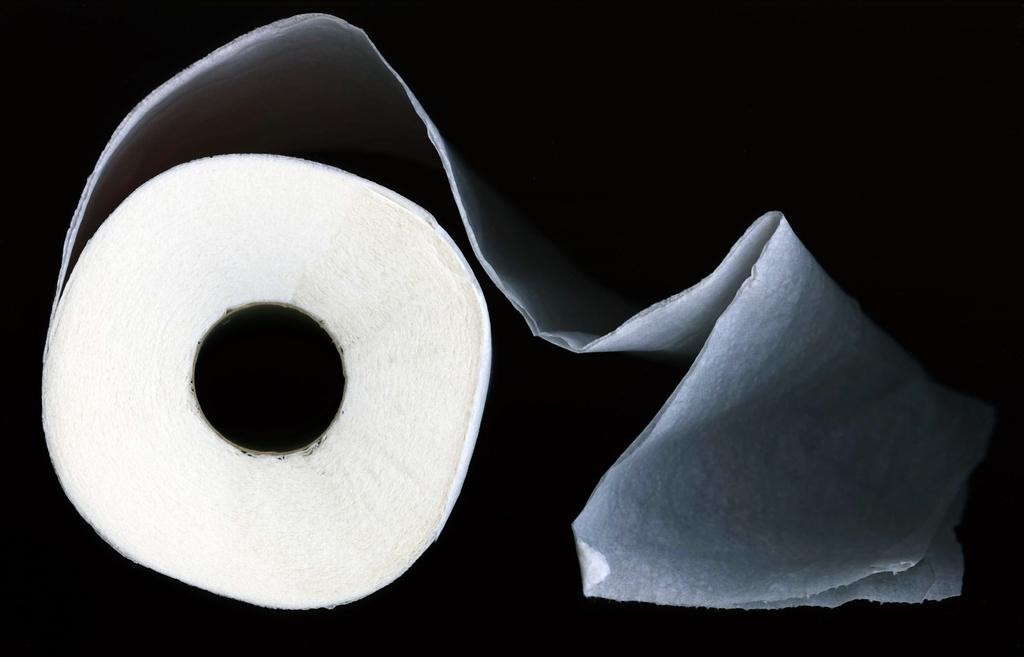What object is located in the front of the image? There is a tissue roll in the front of the image. What can be observed about the background of the image? The background of the image is dark. Where is the mailbox located in the image? There is no mailbox present in the image. What type of rail is visible in the image? There is no rail present in the image. 